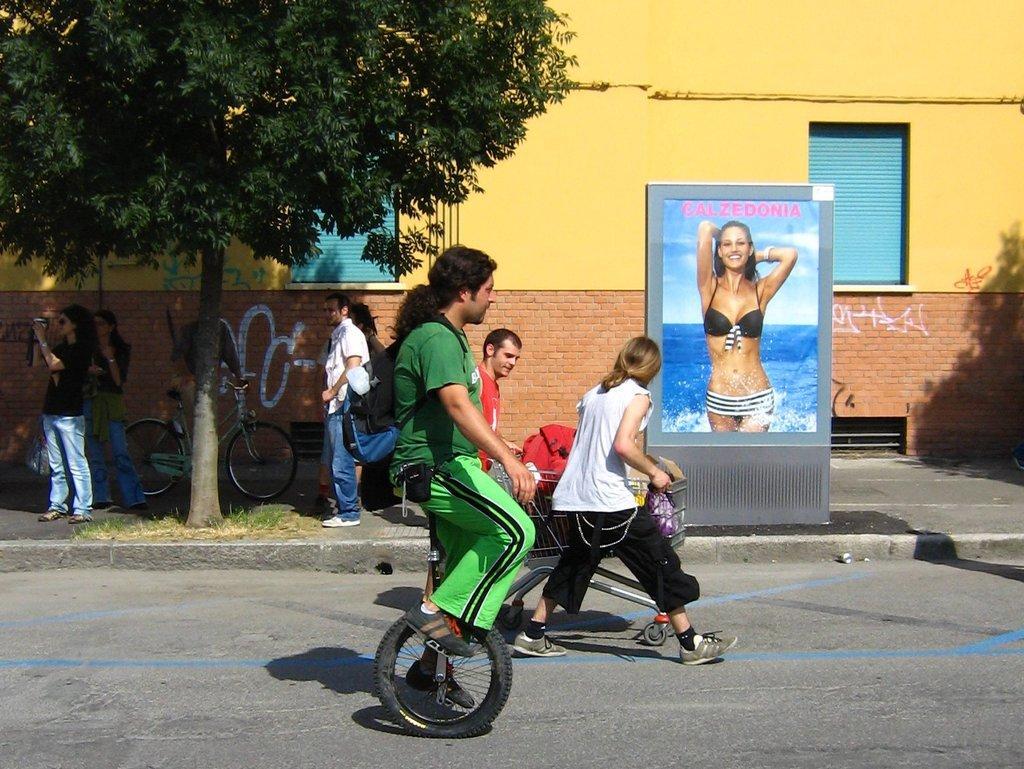Can you describe this image briefly? A man is riding the unicycle. He wore green color dress, on the right side there is a poster of a hot girl. On the left side few people are standing and this is the wall in yellow color. 